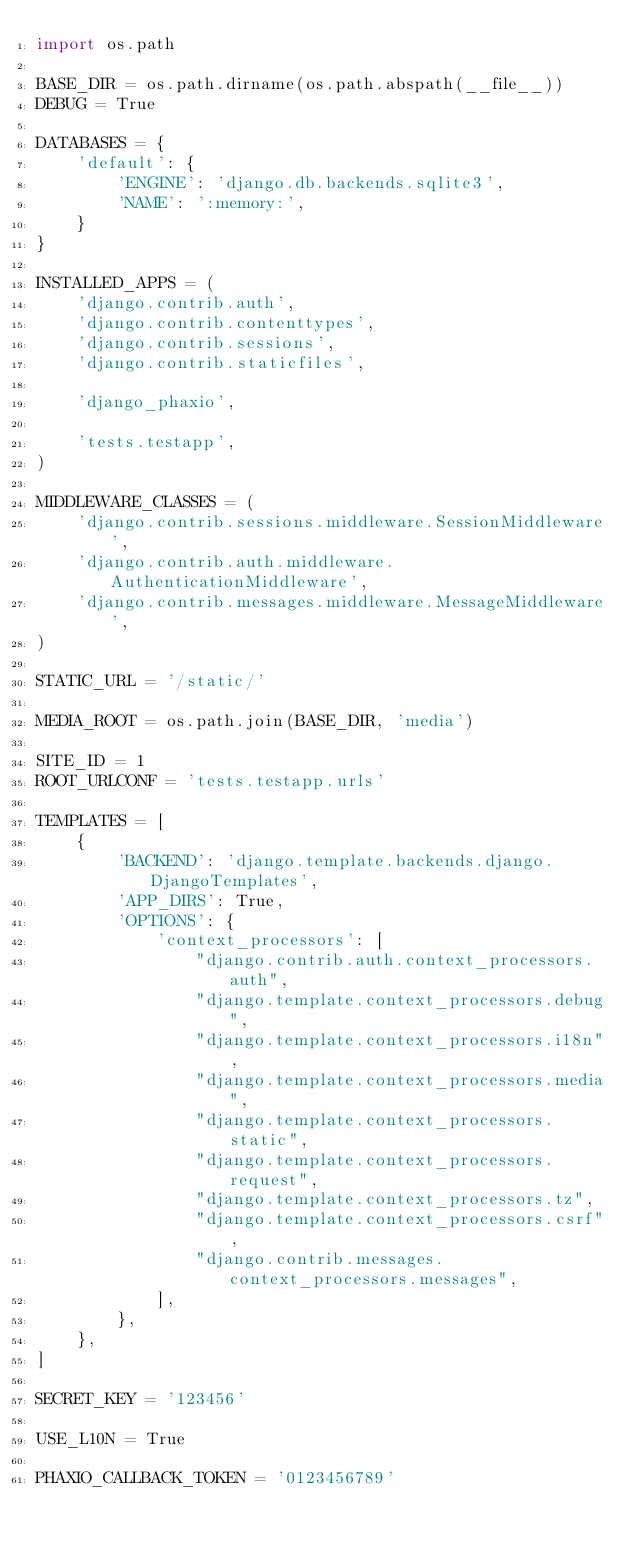<code> <loc_0><loc_0><loc_500><loc_500><_Python_>import os.path

BASE_DIR = os.path.dirname(os.path.abspath(__file__))
DEBUG = True

DATABASES = {
    'default': {
        'ENGINE': 'django.db.backends.sqlite3',
        'NAME': ':memory:',
    }
}

INSTALLED_APPS = (
    'django.contrib.auth',
    'django.contrib.contenttypes',
    'django.contrib.sessions',
    'django.contrib.staticfiles',

    'django_phaxio',

    'tests.testapp',
)

MIDDLEWARE_CLASSES = (
    'django.contrib.sessions.middleware.SessionMiddleware',
    'django.contrib.auth.middleware.AuthenticationMiddleware',
    'django.contrib.messages.middleware.MessageMiddleware',
)

STATIC_URL = '/static/'

MEDIA_ROOT = os.path.join(BASE_DIR, 'media')

SITE_ID = 1
ROOT_URLCONF = 'tests.testapp.urls'

TEMPLATES = [
    {
        'BACKEND': 'django.template.backends.django.DjangoTemplates',
        'APP_DIRS': True,
        'OPTIONS': {
            'context_processors': [
                "django.contrib.auth.context_processors.auth",
                "django.template.context_processors.debug",
                "django.template.context_processors.i18n",
                "django.template.context_processors.media",
                "django.template.context_processors.static",
                "django.template.context_processors.request",
                "django.template.context_processors.tz",
                "django.template.context_processors.csrf",
                "django.contrib.messages.context_processors.messages",
            ],
        },
    },
]

SECRET_KEY = '123456'

USE_L10N = True

PHAXIO_CALLBACK_TOKEN = '0123456789'
</code> 